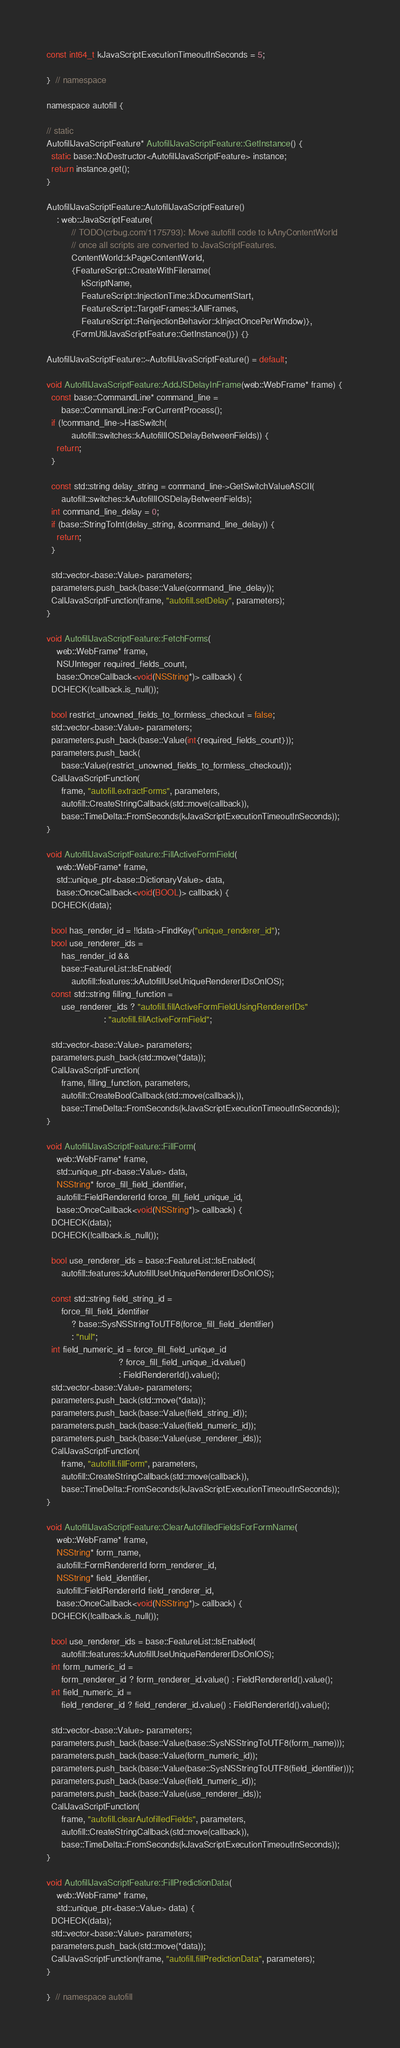<code> <loc_0><loc_0><loc_500><loc_500><_ObjectiveC_>const int64_t kJavaScriptExecutionTimeoutInSeconds = 5;

}  // namespace

namespace autofill {

// static
AutofillJavaScriptFeature* AutofillJavaScriptFeature::GetInstance() {
  static base::NoDestructor<AutofillJavaScriptFeature> instance;
  return instance.get();
}

AutofillJavaScriptFeature::AutofillJavaScriptFeature()
    : web::JavaScriptFeature(
          // TODO(crbug.com/1175793): Move autofill code to kAnyContentWorld
          // once all scripts are converted to JavaScriptFeatures.
          ContentWorld::kPageContentWorld,
          {FeatureScript::CreateWithFilename(
              kScriptName,
              FeatureScript::InjectionTime::kDocumentStart,
              FeatureScript::TargetFrames::kAllFrames,
              FeatureScript::ReinjectionBehavior::kInjectOncePerWindow)},
          {FormUtilJavaScriptFeature::GetInstance()}) {}

AutofillJavaScriptFeature::~AutofillJavaScriptFeature() = default;

void AutofillJavaScriptFeature::AddJSDelayInFrame(web::WebFrame* frame) {
  const base::CommandLine* command_line =
      base::CommandLine::ForCurrentProcess();
  if (!command_line->HasSwitch(
          autofill::switches::kAutofillIOSDelayBetweenFields)) {
    return;
  }

  const std::string delay_string = command_line->GetSwitchValueASCII(
      autofill::switches::kAutofillIOSDelayBetweenFields);
  int command_line_delay = 0;
  if (base::StringToInt(delay_string, &command_line_delay)) {
    return;
  }

  std::vector<base::Value> parameters;
  parameters.push_back(base::Value(command_line_delay));
  CallJavaScriptFunction(frame, "autofill.setDelay", parameters);
}

void AutofillJavaScriptFeature::FetchForms(
    web::WebFrame* frame,
    NSUInteger required_fields_count,
    base::OnceCallback<void(NSString*)> callback) {
  DCHECK(!callback.is_null());

  bool restrict_unowned_fields_to_formless_checkout = false;
  std::vector<base::Value> parameters;
  parameters.push_back(base::Value(int{required_fields_count}));
  parameters.push_back(
      base::Value(restrict_unowned_fields_to_formless_checkout));
  CallJavaScriptFunction(
      frame, "autofill.extractForms", parameters,
      autofill::CreateStringCallback(std::move(callback)),
      base::TimeDelta::FromSeconds(kJavaScriptExecutionTimeoutInSeconds));
}

void AutofillJavaScriptFeature::FillActiveFormField(
    web::WebFrame* frame,
    std::unique_ptr<base::DictionaryValue> data,
    base::OnceCallback<void(BOOL)> callback) {
  DCHECK(data);

  bool has_render_id = !!data->FindKey("unique_renderer_id");
  bool use_renderer_ids =
      has_render_id &&
      base::FeatureList::IsEnabled(
          autofill::features::kAutofillUseUniqueRendererIDsOnIOS);
  const std::string filling_function =
      use_renderer_ids ? "autofill.fillActiveFormFieldUsingRendererIDs"
                       : "autofill.fillActiveFormField";

  std::vector<base::Value> parameters;
  parameters.push_back(std::move(*data));
  CallJavaScriptFunction(
      frame, filling_function, parameters,
      autofill::CreateBoolCallback(std::move(callback)),
      base::TimeDelta::FromSeconds(kJavaScriptExecutionTimeoutInSeconds));
}

void AutofillJavaScriptFeature::FillForm(
    web::WebFrame* frame,
    std::unique_ptr<base::Value> data,
    NSString* force_fill_field_identifier,
    autofill::FieldRendererId force_fill_field_unique_id,
    base::OnceCallback<void(NSString*)> callback) {
  DCHECK(data);
  DCHECK(!callback.is_null());

  bool use_renderer_ids = base::FeatureList::IsEnabled(
      autofill::features::kAutofillUseUniqueRendererIDsOnIOS);

  const std::string field_string_id =
      force_fill_field_identifier
          ? base::SysNSStringToUTF8(force_fill_field_identifier)
          : "null";
  int field_numeric_id = force_fill_field_unique_id
                             ? force_fill_field_unique_id.value()
                             : FieldRendererId().value();
  std::vector<base::Value> parameters;
  parameters.push_back(std::move(*data));
  parameters.push_back(base::Value(field_string_id));
  parameters.push_back(base::Value(field_numeric_id));
  parameters.push_back(base::Value(use_renderer_ids));
  CallJavaScriptFunction(
      frame, "autofill.fillForm", parameters,
      autofill::CreateStringCallback(std::move(callback)),
      base::TimeDelta::FromSeconds(kJavaScriptExecutionTimeoutInSeconds));
}

void AutofillJavaScriptFeature::ClearAutofilledFieldsForFormName(
    web::WebFrame* frame,
    NSString* form_name,
    autofill::FormRendererId form_renderer_id,
    NSString* field_identifier,
    autofill::FieldRendererId field_renderer_id,
    base::OnceCallback<void(NSString*)> callback) {
  DCHECK(!callback.is_null());

  bool use_renderer_ids = base::FeatureList::IsEnabled(
      autofill::features::kAutofillUseUniqueRendererIDsOnIOS);
  int form_numeric_id =
      form_renderer_id ? form_renderer_id.value() : FieldRendererId().value();
  int field_numeric_id =
      field_renderer_id ? field_renderer_id.value() : FieldRendererId().value();

  std::vector<base::Value> parameters;
  parameters.push_back(base::Value(base::SysNSStringToUTF8(form_name)));
  parameters.push_back(base::Value(form_numeric_id));
  parameters.push_back(base::Value(base::SysNSStringToUTF8(field_identifier)));
  parameters.push_back(base::Value(field_numeric_id));
  parameters.push_back(base::Value(use_renderer_ids));
  CallJavaScriptFunction(
      frame, "autofill.clearAutofilledFields", parameters,
      autofill::CreateStringCallback(std::move(callback)),
      base::TimeDelta::FromSeconds(kJavaScriptExecutionTimeoutInSeconds));
}

void AutofillJavaScriptFeature::FillPredictionData(
    web::WebFrame* frame,
    std::unique_ptr<base::Value> data) {
  DCHECK(data);
  std::vector<base::Value> parameters;
  parameters.push_back(std::move(*data));
  CallJavaScriptFunction(frame, "autofill.fillPredictionData", parameters);
}

}  // namespace autofill
</code> 